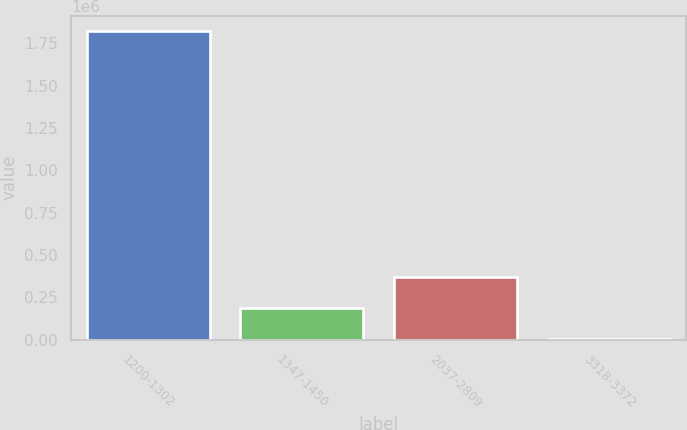Convert chart. <chart><loc_0><loc_0><loc_500><loc_500><bar_chart><fcel>1200-1302<fcel>1347-1450<fcel>2037-2809<fcel>3318-3372<nl><fcel>1.8206e+06<fcel>185917<fcel>367548<fcel>4286<nl></chart> 